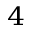<formula> <loc_0><loc_0><loc_500><loc_500>^ { 4 }</formula> 